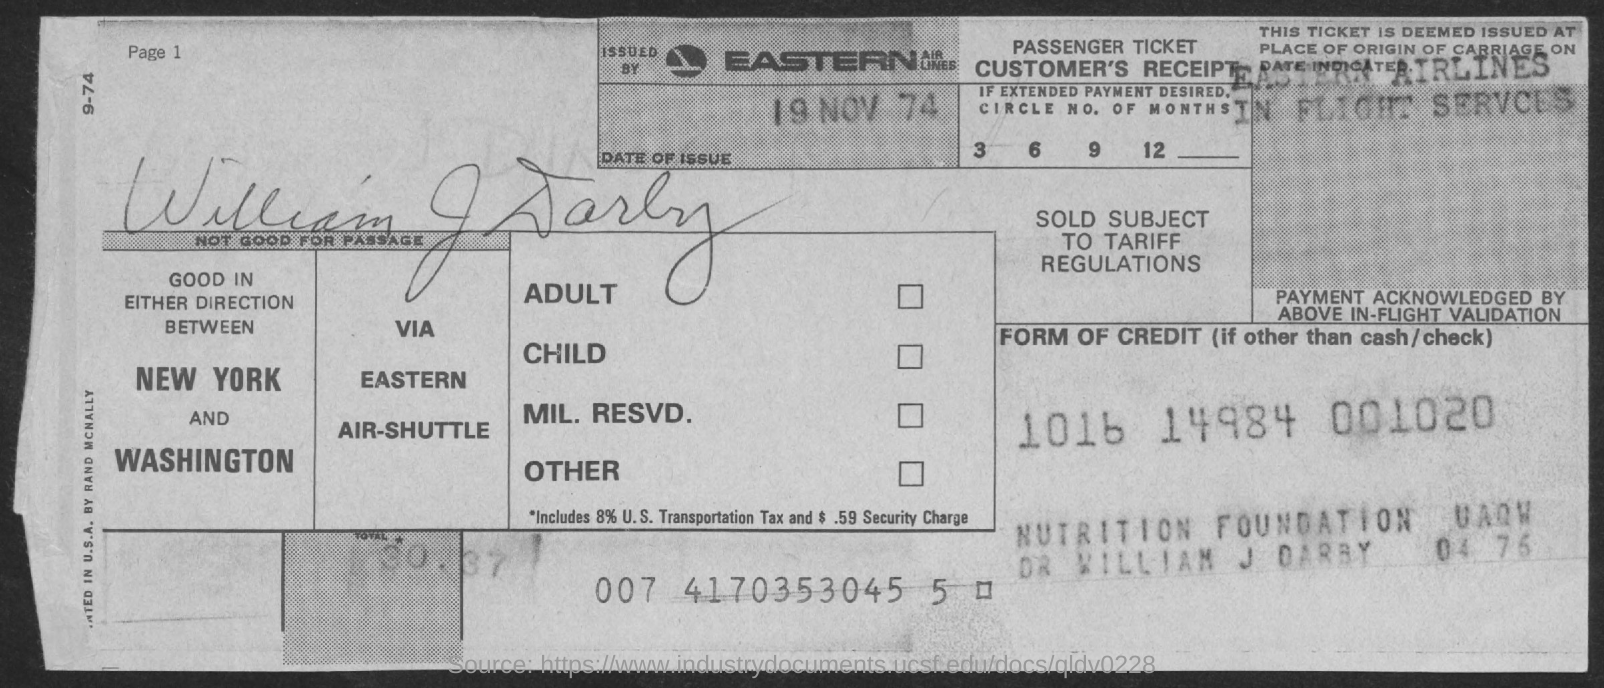List a handful of essential elements in this visual. The date of issue on the receipt is November 19, 1974. The receipt indicates the name of the person as "WILLIAM J DARBY. 